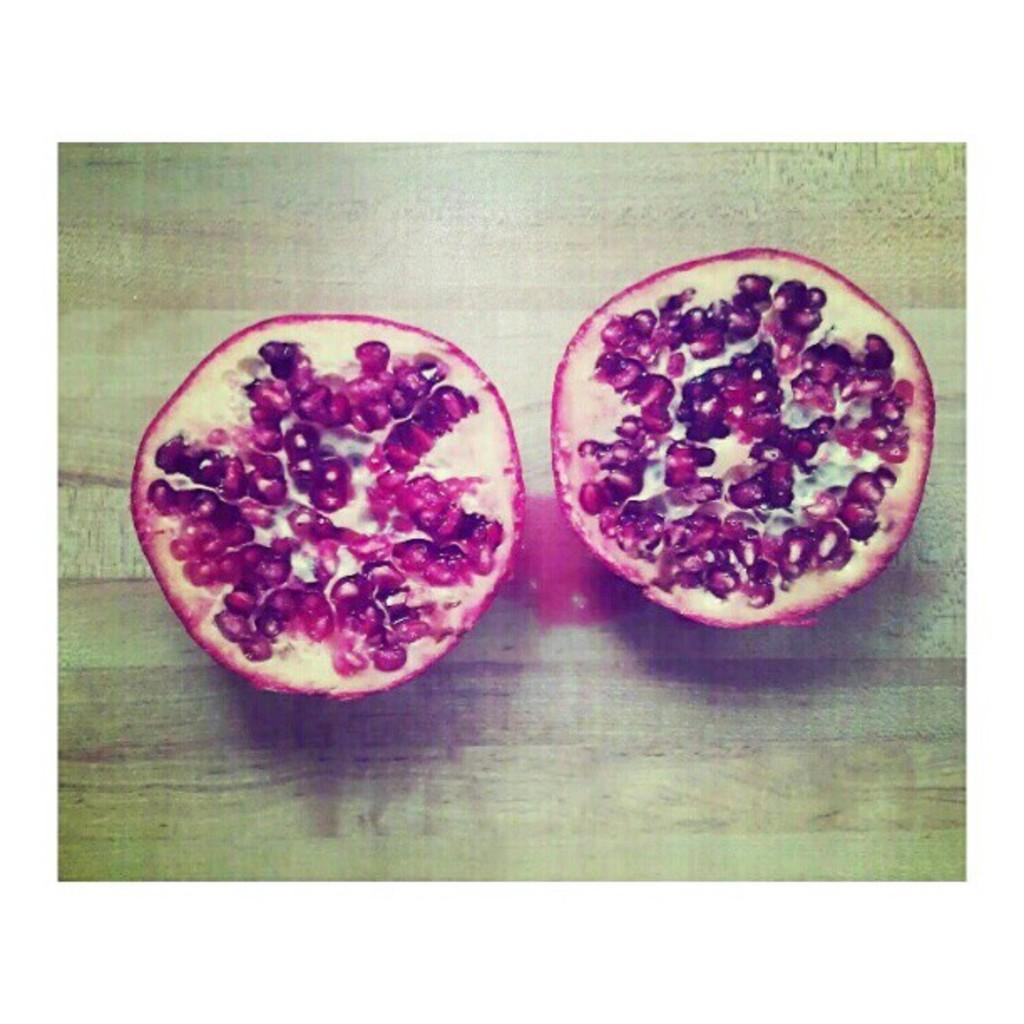What fruit is depicted in the image? There are two slices of a pomegranate in the image. What is the surface made of that the pomegranate slices are placed on? The pomegranate slices are on a wooden surface. How many baseballs can be seen in the image? There are no baseballs present in the image. What type of deer is visible in the image? There are no deer present in the image. 